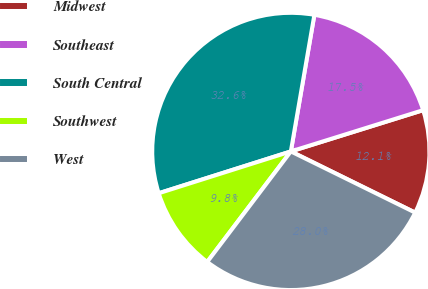<chart> <loc_0><loc_0><loc_500><loc_500><pie_chart><fcel>Midwest<fcel>Southeast<fcel>South Central<fcel>Southwest<fcel>West<nl><fcel>12.09%<fcel>17.47%<fcel>32.59%<fcel>9.81%<fcel>28.03%<nl></chart> 